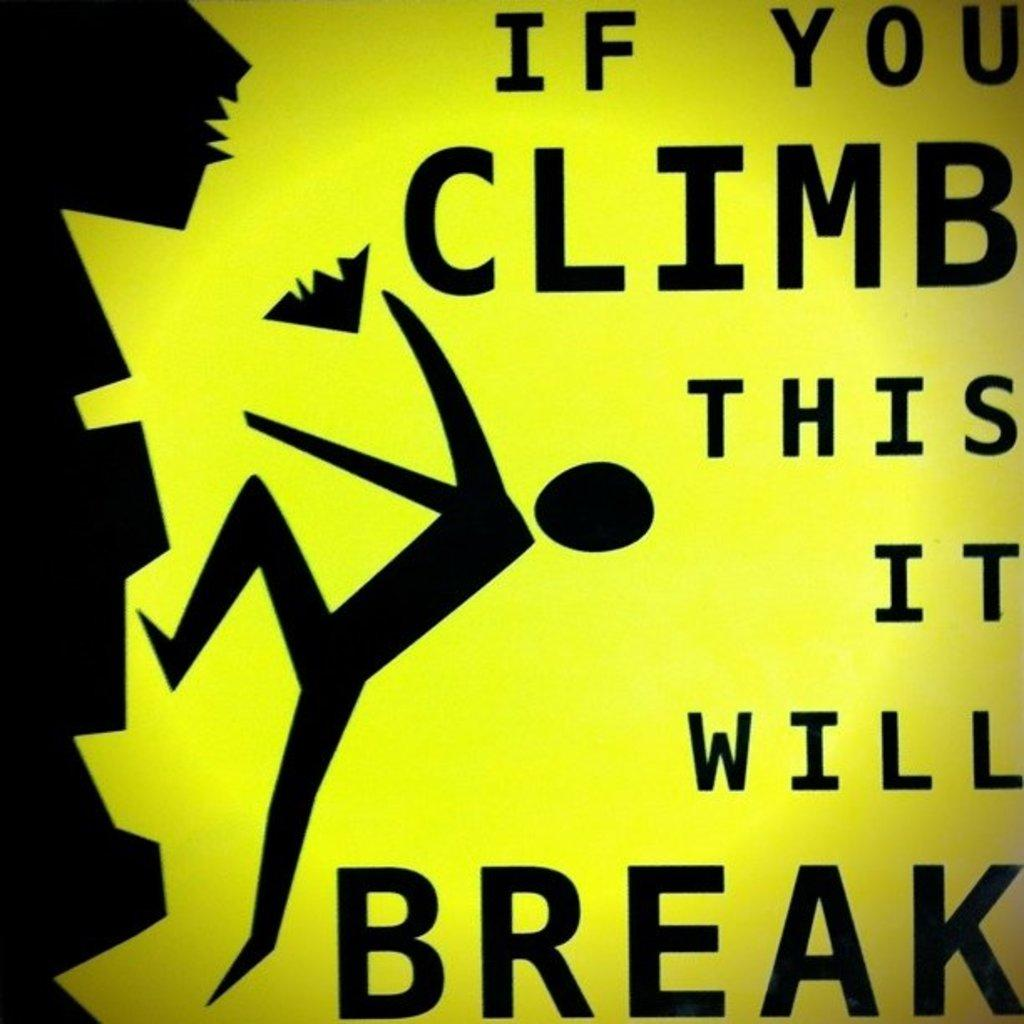<image>
Create a compact narrative representing the image presented. a warning sign about breaking things if you climb them is yellow and black 